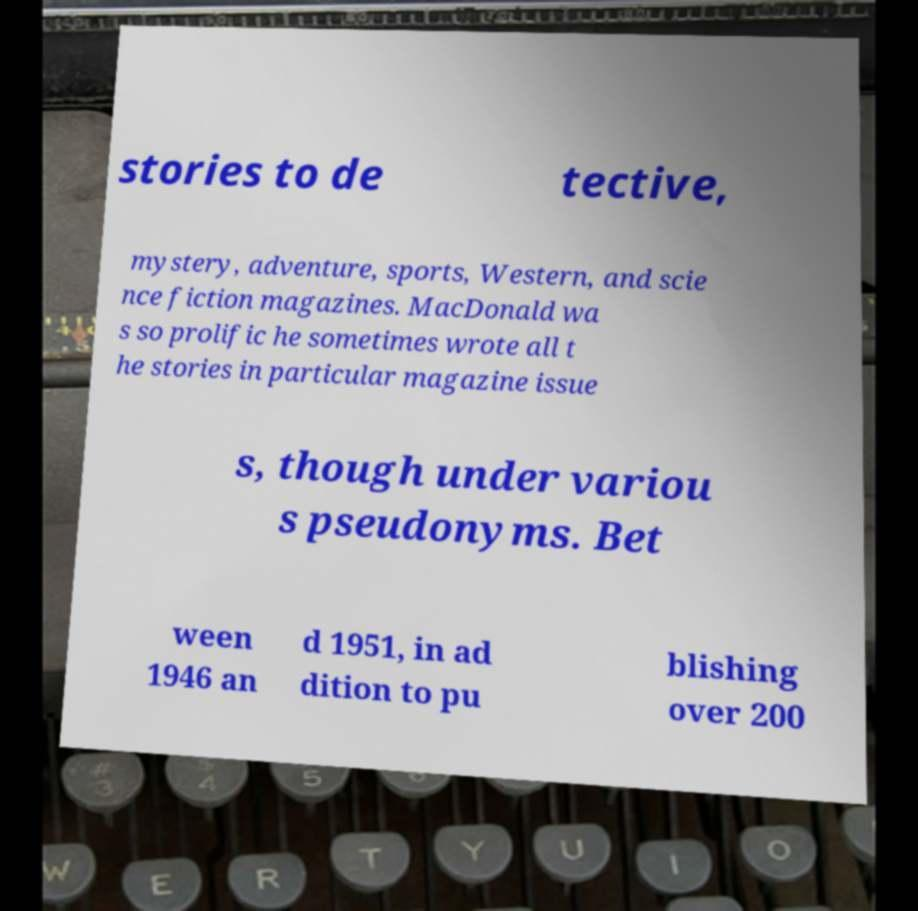Please identify and transcribe the text found in this image. stories to de tective, mystery, adventure, sports, Western, and scie nce fiction magazines. MacDonald wa s so prolific he sometimes wrote all t he stories in particular magazine issue s, though under variou s pseudonyms. Bet ween 1946 an d 1951, in ad dition to pu blishing over 200 